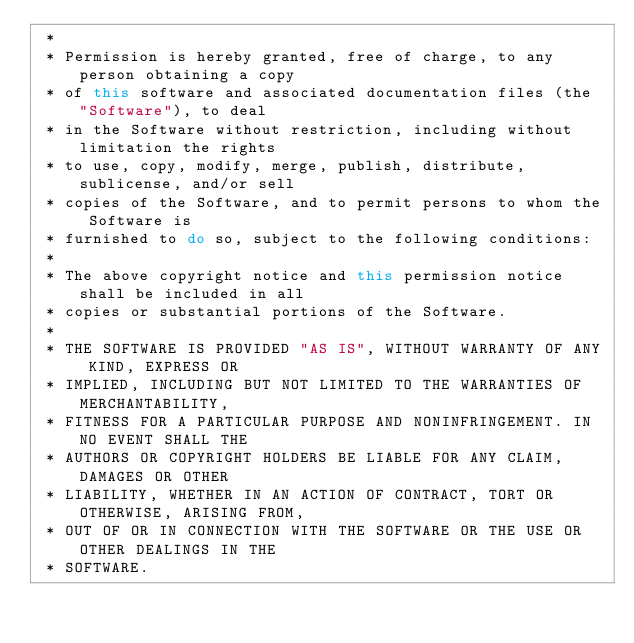Convert code to text. <code><loc_0><loc_0><loc_500><loc_500><_Java_> *
 * Permission is hereby granted, free of charge, to any person obtaining a copy
 * of this software and associated documentation files (the "Software"), to deal
 * in the Software without restriction, including without limitation the rights
 * to use, copy, modify, merge, publish, distribute, sublicense, and/or sell
 * copies of the Software, and to permit persons to whom the Software is
 * furnished to do so, subject to the following conditions:
 *
 * The above copyright notice and this permission notice shall be included in all
 * copies or substantial portions of the Software.
 *
 * THE SOFTWARE IS PROVIDED "AS IS", WITHOUT WARRANTY OF ANY KIND, EXPRESS OR
 * IMPLIED, INCLUDING BUT NOT LIMITED TO THE WARRANTIES OF MERCHANTABILITY,
 * FITNESS FOR A PARTICULAR PURPOSE AND NONINFRINGEMENT. IN NO EVENT SHALL THE
 * AUTHORS OR COPYRIGHT HOLDERS BE LIABLE FOR ANY CLAIM, DAMAGES OR OTHER
 * LIABILITY, WHETHER IN AN ACTION OF CONTRACT, TORT OR OTHERWISE, ARISING FROM,
 * OUT OF OR IN CONNECTION WITH THE SOFTWARE OR THE USE OR OTHER DEALINGS IN THE
 * SOFTWARE.</code> 